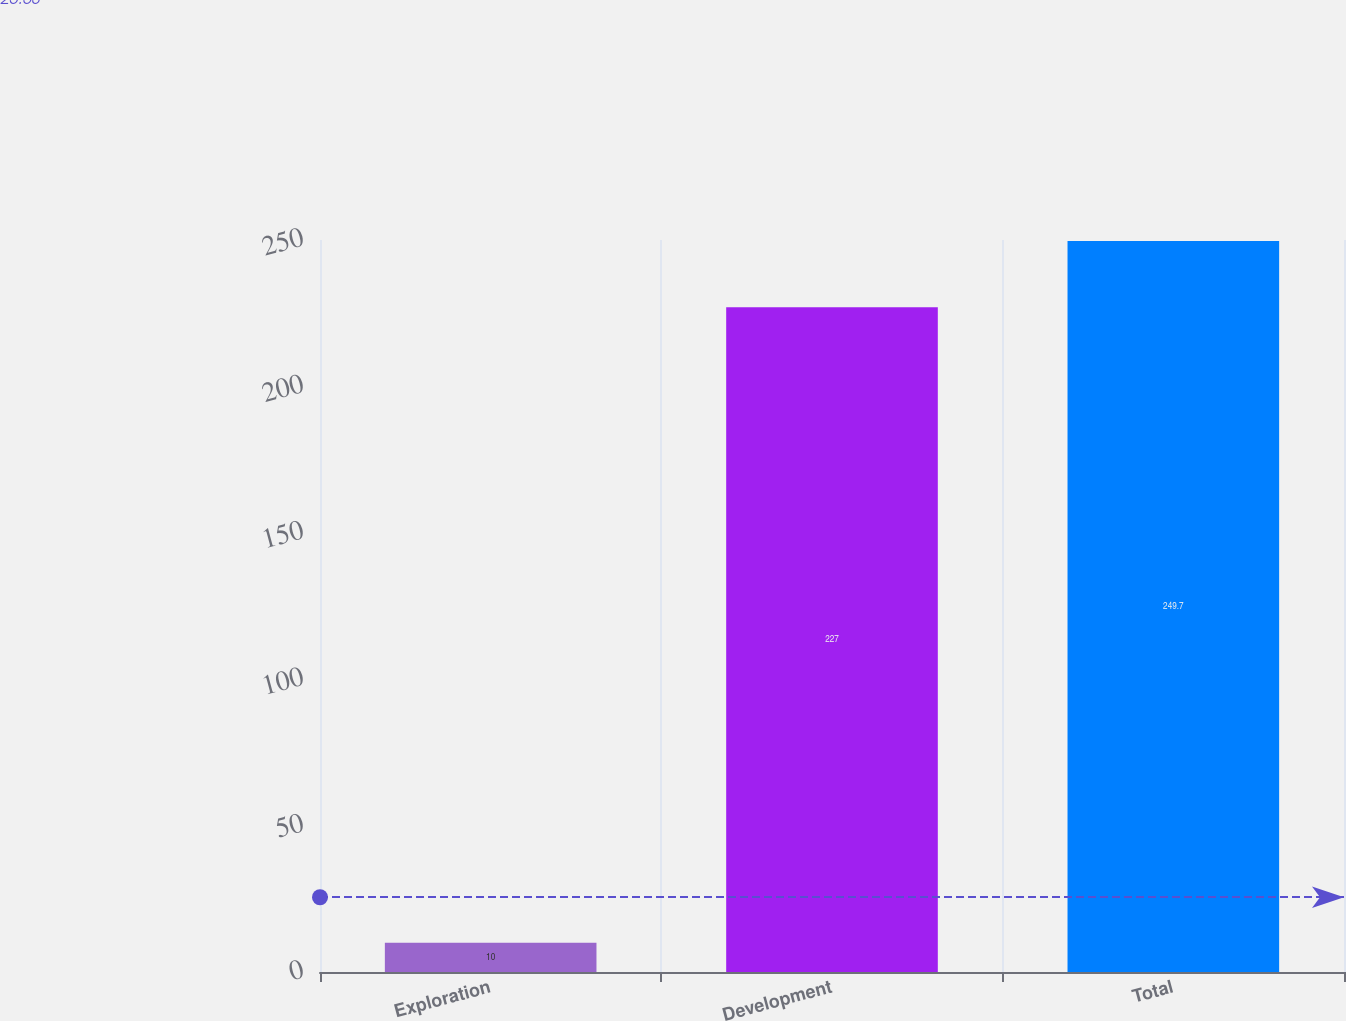Convert chart to OTSL. <chart><loc_0><loc_0><loc_500><loc_500><bar_chart><fcel>Exploration<fcel>Development<fcel>Total<nl><fcel>10<fcel>227<fcel>249.7<nl></chart> 